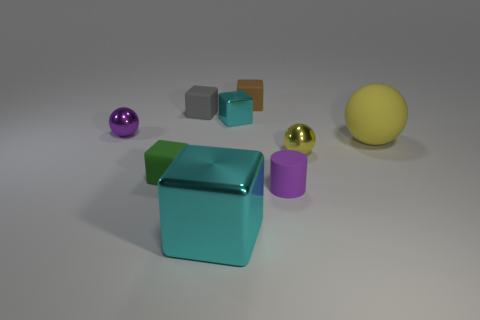Subtract all small cyan metal blocks. How many blocks are left? 4 Subtract all large brown cylinders. Subtract all tiny cyan blocks. How many objects are left? 8 Add 9 tiny purple metallic things. How many tiny purple metallic things are left? 10 Add 8 yellow balls. How many yellow balls exist? 10 Add 1 small brown rubber cubes. How many objects exist? 10 Subtract all yellow balls. How many balls are left? 1 Subtract 0 brown cylinders. How many objects are left? 9 Subtract all cylinders. How many objects are left? 8 Subtract all blue balls. Subtract all red cylinders. How many balls are left? 3 Subtract all gray balls. How many gray cubes are left? 1 